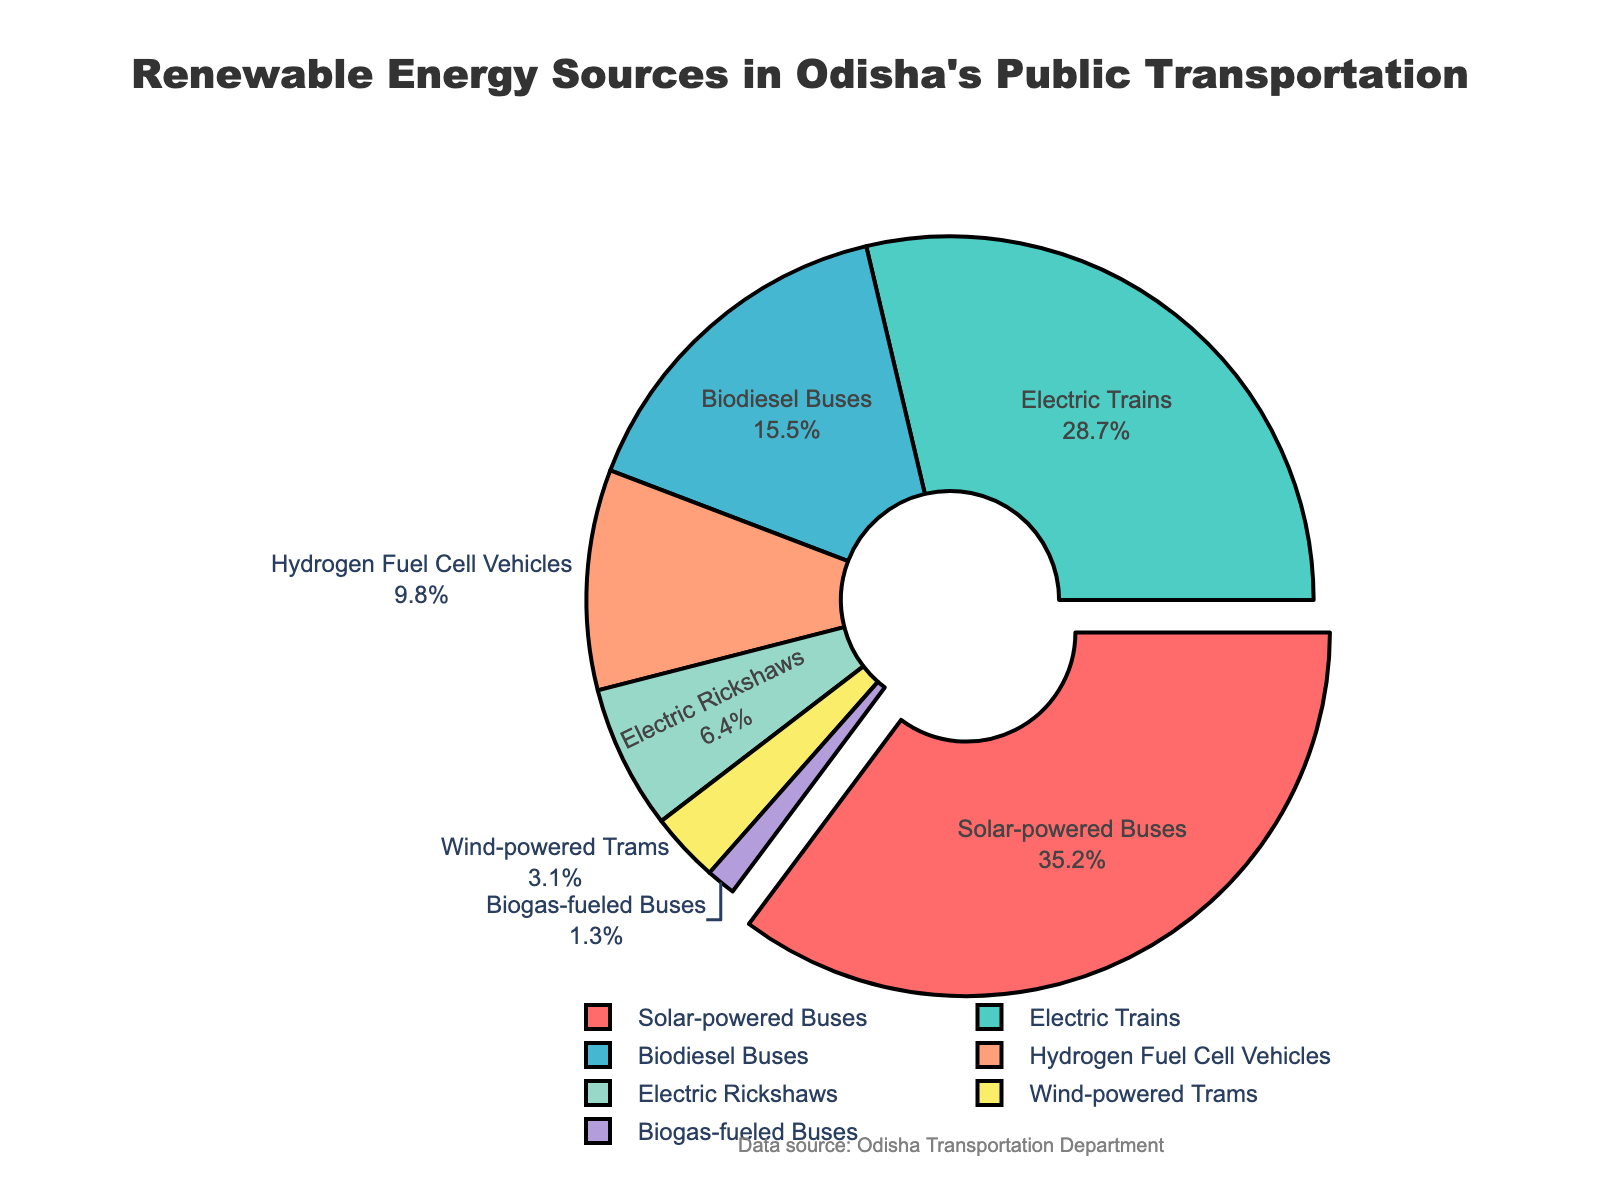What is the most used renewable energy source in Odisha's public transportation system? The largest segment in the pie chart represents Solar-powered Buses with 35.2%.
Answer: Solar-powered Buses Which renewable energy source has the smallest share? The smallest segment in the pie chart represents Biogas-fueled Buses with 1.3%.
Answer: Biogas-fueled Buses How much more percentage do Solar-powered Buses contribute compared to Hydrogen Fuel Cell Vehicles? Calculate the difference in their percentages: 35.2% (Solar-powered Buses) - 9.8% (Hydrogen Fuel Cell Vehicles) = 25.4%.
Answer: 25.4% What is the combined percentage of Electric Rickshaws and Wind-powered Trams? Sum their individual percentages: 6.4% (Electric Rickshaws) + 3.1% (Wind-powered Trams) = 9.5%.
Answer: 9.5% Which two renewable energy sources share a combined contribution closest to Hydrogen Fuel Cell Vehicles? By checking combinations, Electric Rickshaws (6.4%) + Wind-powered Trams (3.1%) equals 9.5% which is closest to 9.8% (Hydrogen Fuel Cell Vehicles).
Answer: Electric Rickshaws and Wind-powered Trams Are Electric Rickshaws contributing more or less than 10% of the total? The pie chart shows Electric Rickshaws contributing 6.4%, which is less than 10%.
Answer: Less Among non-electric sources (Biodiesel Buses, Hydrogen Fuel Cell Vehicles, and Biogas-fueled Buses), which one has the highest share? The largest segment among the non-electric sources is Biodiesel Buses with 15.5%.
Answer: Biodiesel Buses What is the sum of the percentages of all electric-powered sources (Electric Trains and Electric Rickshaws)? Sum their individual percentages: 28.7% (Electric Trains) + 6.4% (Electric Rickshaws) = 35.1%.
Answer: 35.1% If the total share of renewable energy sources in Odisha's public transportation is represented by 100%, what percentage do non-electric sources (Biodiesel Buses, Hydrogen Fuel Cell Vehicles, Wind-powered Trams, and Biogas-fueled Buses) contribute in total? Sum their individual percentages: 15.5% (Biodiesel Buses) + 9.8% (Hydrogen Fuel Cell Vehicles) + 3.1% (Wind-powered Trams) + 1.3% (Biogas-fueled Buses) = 29.7%.
Answer: 29.7% Which segment is pulled out slightly from the pie chart and why? The segment representing Solar-powered Buses is pulled out slightly because it has the largest share at 35.2%.
Answer: Solar-powered Buses 